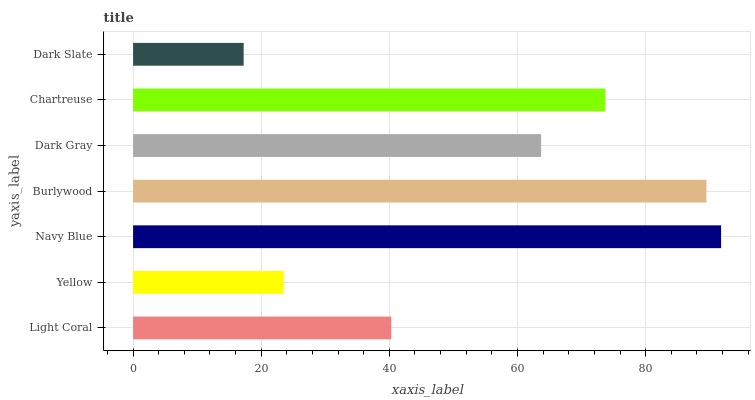Is Dark Slate the minimum?
Answer yes or no. Yes. Is Navy Blue the maximum?
Answer yes or no. Yes. Is Yellow the minimum?
Answer yes or no. No. Is Yellow the maximum?
Answer yes or no. No. Is Light Coral greater than Yellow?
Answer yes or no. Yes. Is Yellow less than Light Coral?
Answer yes or no. Yes. Is Yellow greater than Light Coral?
Answer yes or no. No. Is Light Coral less than Yellow?
Answer yes or no. No. Is Dark Gray the high median?
Answer yes or no. Yes. Is Dark Gray the low median?
Answer yes or no. Yes. Is Yellow the high median?
Answer yes or no. No. Is Navy Blue the low median?
Answer yes or no. No. 